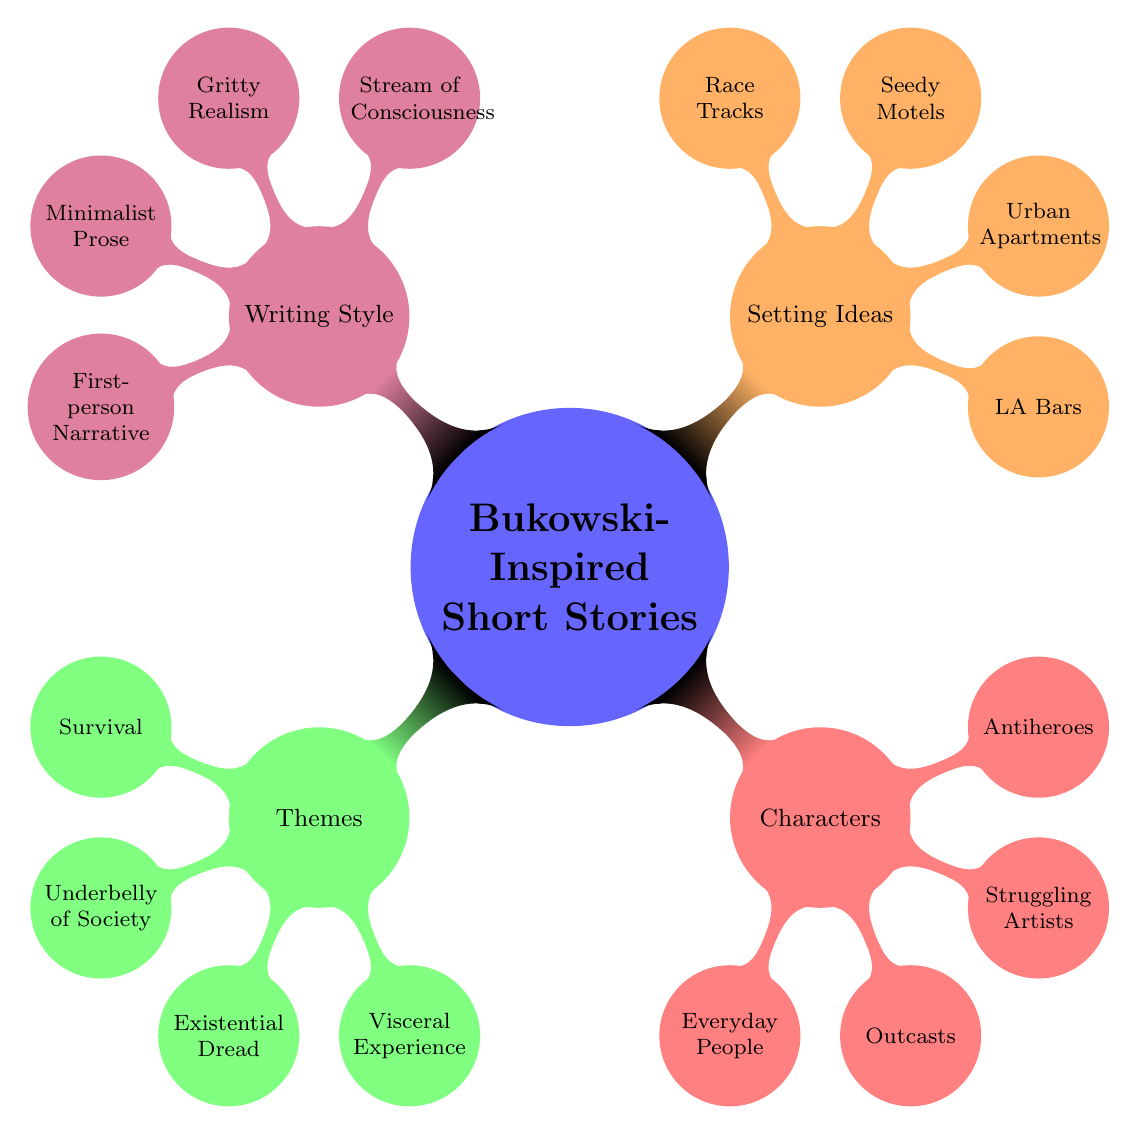What are the four themes of the short stories? The diagram shows a list of four themes associated with Bukowski-inspired short stories: Survival, Underbelly of Society, Existential Dread, and Visceral Experience. This can be directly counted from the thematic node.
Answer: Survival, Underbelly of Society, Existential Dread, Visceral Experience How many characters are there in the list? The character node lists four types: Everyday People, Outcasts, Struggling Artists, and Antiheroes. We can simply count the nodes under the Characters category.
Answer: 4 What are the setting ideas mentioned in the mind map? The setting ideas include LA Bars, Urban Apartments, Seedy Motels, and Race Tracks. This information is directly obtainable from the node labeled Setting Ideas in the diagram.
Answer: LA Bars, Urban Apartments, Seedy Motels, Race Tracks Which writing style is listed first? The first writing style mentioned in the node Writing Style is Stream of Consciousness. We find this by looking at the Writing Style node and identifying the first child node.
Answer: Stream of Consciousness How many nodes are under Writing Style? There are four styles listed: Stream of Consciousness, Gritty Realism, Minimalist Prose, and First-person Narrative. To find this, we simply count all the child nodes under the Writing Style category.
Answer: 4 Which character type represents those marginalized by society? The character type Outcasts embodies those marginalized by society, as reflected in the Characters node. This can be inferred by interpreting the meaning behind the classifications presented in the diagram.
Answer: Outcasts Are there any themes related to mental states in the short stories? Existential Dread is a theme that relates directly to mental states, as it is concerned with the nature of existence and human experiences. This is inferred from the theme nodes, specifically identifying which ones imply deeper psychological themes.
Answer: Existential Dread 